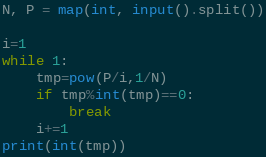Convert code to text. <code><loc_0><loc_0><loc_500><loc_500><_Python_>N, P = map(int, input().split())

i=1
while 1:
    tmp=pow(P/i,1/N)
    if tmp%int(tmp)==0:
        break
    i+=1
print(int(tmp))</code> 